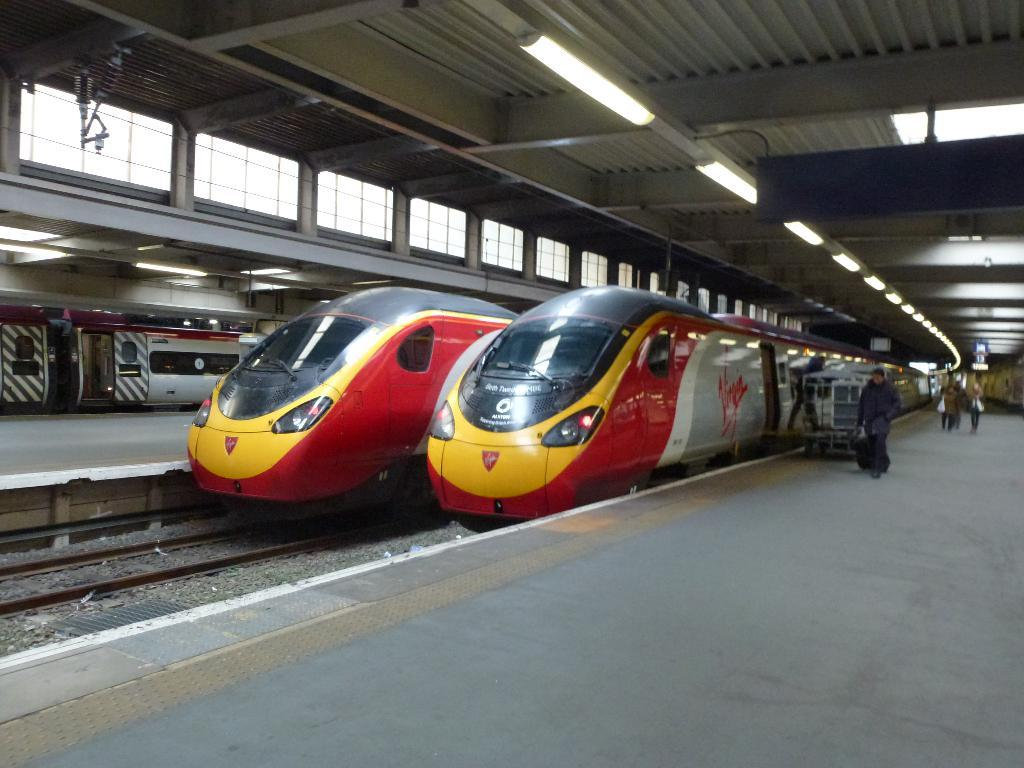<image>
Summarize the visual content of the image. a train that has Virgin on the side 